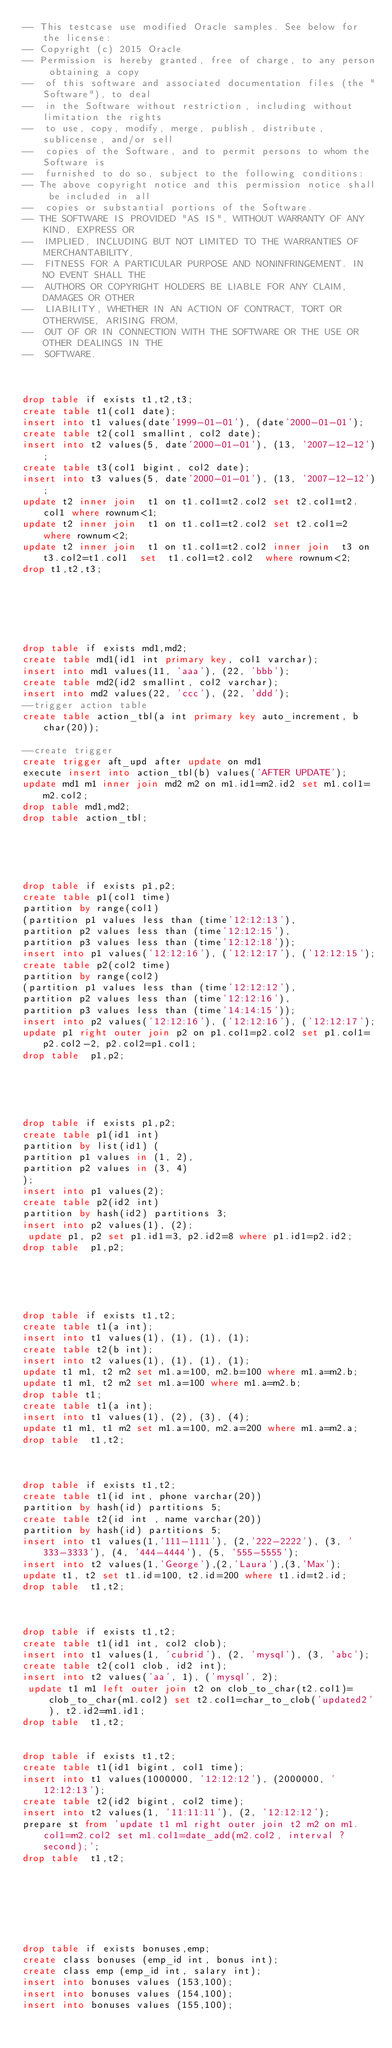<code> <loc_0><loc_0><loc_500><loc_500><_SQL_>-- This testcase use modified Oracle samples. See below for the license:
-- Copyright (c) 2015 Oracle
-- Permission is hereby granted, free of charge, to any person obtaining a copy
--  of this software and associated documentation files (the "Software"), to deal
--  in the Software without restriction, including without limitation the rights
--  to use, copy, modify, merge, publish, distribute, sublicense, and/or sell
--  copies of the Software, and to permit persons to whom the Software is
--  furnished to do so, subject to the following conditions:
-- The above copyright notice and this permission notice shall be included in all
--  copies or substantial portions of the Software.
-- THE SOFTWARE IS PROVIDED "AS IS", WITHOUT WARRANTY OF ANY KIND, EXPRESS OR
--  IMPLIED, INCLUDING BUT NOT LIMITED TO THE WARRANTIES OF MERCHANTABILITY,
--  FITNESS FOR A PARTICULAR PURPOSE AND NONINFRINGEMENT. IN NO EVENT SHALL THE
--  AUTHORS OR COPYRIGHT HOLDERS BE LIABLE FOR ANY CLAIM, DAMAGES OR OTHER
--  LIABILITY, WHETHER IN AN ACTION OF CONTRACT, TORT OR OTHERWISE, ARISING FROM,
--  OUT OF OR IN CONNECTION WITH THE SOFTWARE OR THE USE OR OTHER DEALINGS IN THE
--  SOFTWARE.



drop table if exists t1,t2,t3;
create table t1(col1 date);
insert into t1 values(date'1999-01-01'), (date'2000-01-01');
create table t2(col1 smallint, col2 date);
insert into t2 values(5, date'2000-01-01'), (13, '2007-12-12');
create table t3(col1 bigint, col2 date);
insert into t3 values(5, date'2000-01-01'), (13, '2007-12-12');
update t2 inner join  t1 on t1.col1=t2.col2 set t2.col1=t2.col1 where rownum<1;
update t2 inner join  t1 on t1.col1=t2.col2 set t2.col1=2 where rownum<2;
update t2 inner join  t1 on t1.col1=t2.col2 inner join  t3 on t3.col2=t1.col1  set  t1.col1=t2.col2  where rownum<2;
drop t1,t2,t3;






drop table if exists md1,md2;
create table md1(id1 int primary key, col1 varchar);
insert into md1 values(11, 'aaa'), (22, 'bbb');
create table md2(id2 smallint, col2 varchar);
insert into md2 values(22, 'ccc'), (22, 'ddd');
--trigger action table
create table action_tbl(a int primary key auto_increment, b char(20));

--create trigger
create trigger aft_upd after update on md1
execute insert into action_tbl(b) values('AFTER UPDATE');
update md1 m1 inner join md2 m2 on m1.id1=m2.id2 set m1.col1=m2.col2;
drop table md1,md2;
drop table action_tbl;





drop table if exists p1,p2;
create table p1(col1 time)
partition by range(col1)
(partition p1 values less than (time'12:12:13'),
partition p2 values less than (time'12:12:15'),
partition p3 values less than (time'12:12:18'));
insert into p1 values('12:12:16'), ('12:12:17'), ('12:12:15');
create table p2(col2 time)
partition by range(col2)
(partition p1 values less than (time'12:12:12'),
partition p2 values less than (time'12:12:16'),
partition p3 values less than (time'14:14:15'));
insert into p2 values('12:12:16'), ('12:12:16'), ('12:12:17');
update p1 right outer join p2 on p1.col1=p2.col2 set p1.col1=p2.col2-2, p2.col2=p1.col1;
drop table  p1,p2;





drop table if exists p1,p2;
create table p1(id1 int)
partition by list(id1) (
partition p1 values in (1, 2),
partition p2 values in (3, 4)
);
insert into p1 values(2);
create table p2(id2 int)
partition by hash(id2) partitions 3;
insert into p2 values(1), (2);
 update p1, p2 set p1.id1=3, p2.id2=8 where p1.id1=p2.id2;
drop table  p1,p2;





drop table if exists t1,t2;
create table t1(a int);
insert into t1 values(1), (1), (1), (1);
create table t2(b int);
insert into t2 values(1), (1), (1), (1);
update t1 m1, t2 m2 set m1.a=100, m2.b=100 where m1.a=m2.b;
update t1 m1, t2 m2 set m1.a=100 where m1.a=m2.b;
drop table t1;
create table t1(a int);
insert into t1 values(1), (2), (3), (4);
update t1 m1, t1 m2 set m1.a=100, m2.a=200 where m1.a=m2.a;
drop table  t1,t2;



drop table if exists t1,t2;
create table t1(id int, phone varchar(20)) 
partition by hash(id) partitions 5;
create table t2(id int , name varchar(20))
partition by hash(id) partitions 5;
insert into t1 values(1,'111-1111'), (2,'222-2222'), (3, '333-3333'), (4, '444-4444'), (5, '555-5555');
insert into t2 values(1,'George'),(2,'Laura'),(3,'Max');
update t1, t2 set t1.id=100, t2.id=200 where t1.id=t2.id;
drop table  t1,t2;



drop table if exists t1,t2;
create table t1(id1 int, col2 clob);
insert into t1 values(1, 'cubrid'), (2, 'mysql'), (3, 'abc');
create table t2(col1 clob, id2 int);
insert into t2 values('aa', 1), ('mysql', 2);
 update t1 m1 left outer join t2 on clob_to_char(t2.col1)=clob_to_char(m1.col2) set t2.col1=char_to_clob('updated2'), t2.id2=m1.id1;
drop table  t1,t2;


drop table if exists t1,t2;
create table t1(id1 bigint, col1 time);
insert into t1 values(1000000, '12:12:12'), (2000000, '12:12:13');
create table t2(id2 bigint, col2 time);
insert into t2 values(1, '11:11:11'), (2, '12:12:12');
prepare st from 'update t1 m1 right outer join t2 m2 on m1.col1=m2.col2 set m1.col1=date_add(m2.col2, interval ? second);';
drop table  t1,t2;







drop table if exists bonuses,emp;
create class bonuses (emp_id int, bonus int);
create class emp (emp_id int, salary int);
insert into bonuses values (153,100);
insert into bonuses values (154,100);
insert into bonuses values (155,100);</code> 